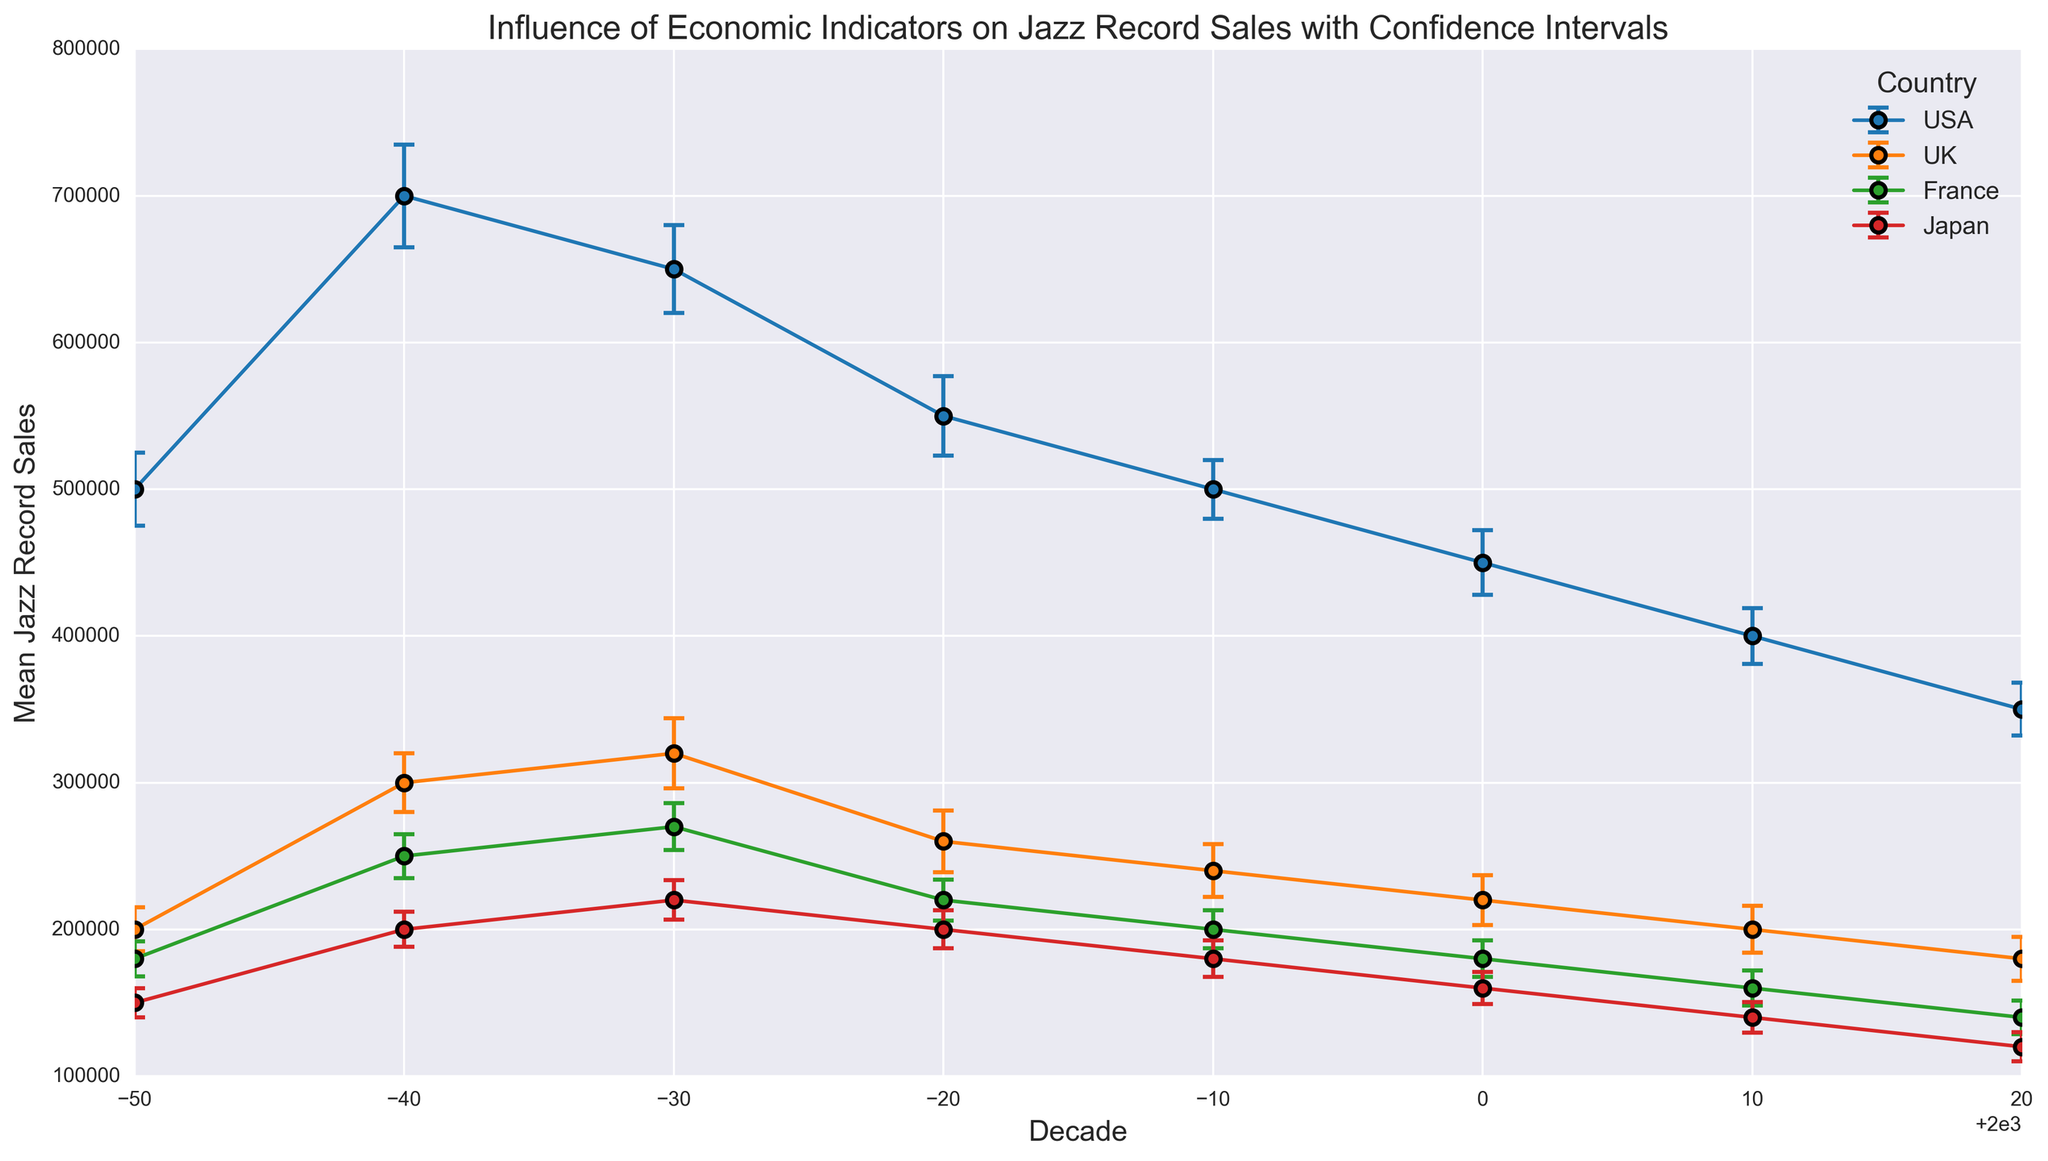What is the general trend of jazz record sales in the USA from 1950 to 2020? Look at the error bars for the USA from 1950 to 2020. Notice that the mean jazz record sales decrease over time, with some fluctuations but a clear decreasing trend overall.
Answer: Decreasing Which country had the highest mean jazz record sales in the 1960s? Examine the error bars for all countries in the 1960s. You'll see the USA had the highest mean sales, significantly higher than the UK, France, and Japan.
Answer: USA In which decade did France experience its peak mean jazz record sales? Look at the error bars for France across all decades. Observe that the highest mean sales occurs in the 1970s, peaking at 270,000 sales.
Answer: 1970s How do the variations (standard deviations) in jazz record sales compare between the USA and Japan in 1980? Check the error bars (length) for the USA and Japan in 1980. The USA has longer error bars, indicating a higher variation in sales compared to Japan.
Answer: USA has higher variation Which country has the smallest standard deviation in jazz record sales in the 2020s? Examine the lengths of the error bars for each country in the 2020s. Japan has the smallest error bars, indicating the smallest standard deviation.
Answer: Japan Calculate the average mean jazz record sales for the UK across all decades? For the UK, sum the mean sales for all decades: (200000 + 300000 + 320000 + 260000 + 240000 + 220000 + 200000 + 180000) = 1920000. Now, divide by the number of decades (8).
Answer: 240,000 Which decade saw the largest drop in mean jazz record sales in the USA? Compare the differences in mean sales between subsequent decades for the USA. The largest drop is between 1960 and 1970, where sales fell from 700,000 to 650,000.
Answer: 1960 to 1970 What is the mean difference in jazz record sales between the USA and UK in the 1990s? Subtract the mean sales of the UK (240,000) from the mean sales of the USA (500,000) in the 1990s.
Answer: 260,000 Among the countries plotted, which country's mean sales appeared most stable across the decades? Assess the trend lines of mean sales for each country. Japan's trend is relatively stable compared to the others, with a steady decline without sharp fluctuations.
Answer: Japan 